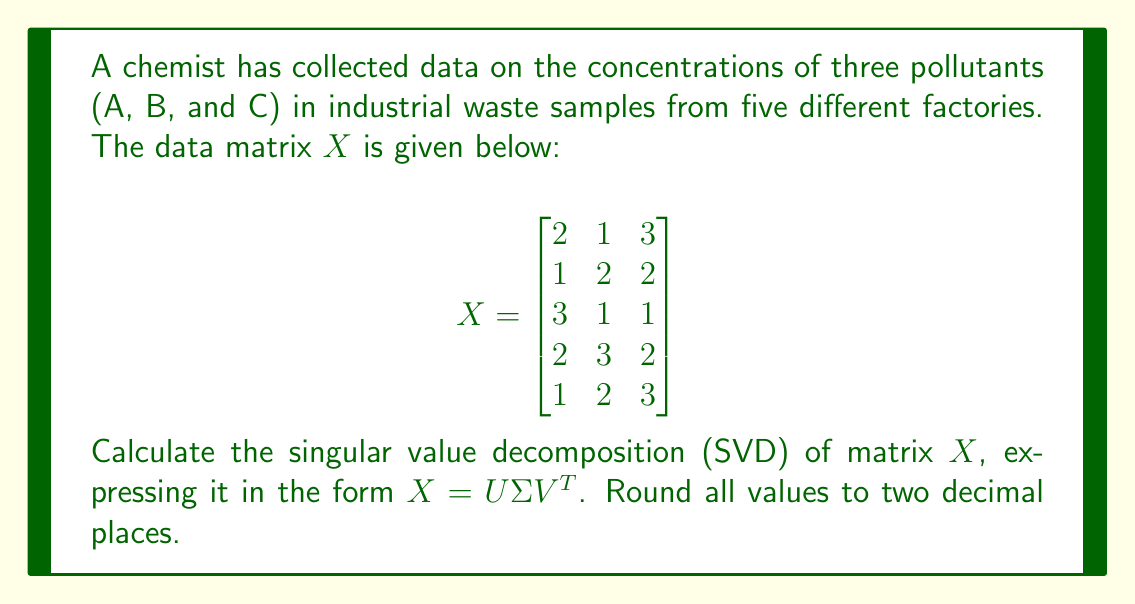Give your solution to this math problem. To calculate the singular value decomposition (SVD) of matrix $X$, we follow these steps:

1. Calculate $X^TX$ and $XX^T$:

   $$X^TX = \begin{bmatrix}
   23 & 19 & 21 \\
   19 & 23 & 21 \\
   21 & 21 & 27
   \end{bmatrix}$$

   $$XX^T = \begin{bmatrix}
   14 & 11 & 11 & 13 & 14 \\
   11 & 9 & 8 & 12 & 11 \\
   11 & 8 & 11 & 11 & 9 \\
   13 & 12 & 11 & 17 & 14 \\
   14 & 11 & 9 & 14 & 14
   \end{bmatrix}$$

2. Find eigenvalues and eigenvectors of $X^TX$:
   Eigenvalues: $\lambda_1 \approx 62.62$, $\lambda_2 \approx 9.38$, $\lambda_3 \approx 1.00$
   
   Corresponding eigenvectors (columns of $V$):
   $$V \approx \begin{bmatrix}
   0.58 & -0.57 & 0.58 \\
   0.57 & 0.82 & 0.00 \\
   0.58 & -0.01 & -0.81
   \end{bmatrix}$$

3. Calculate singular values:
   $\sigma_1 = \sqrt{62.62} \approx 7.91$
   $\sigma_2 = \sqrt{9.38} \approx 3.06$
   $\sigma_3 = \sqrt{1.00} = 1.00$

4. Construct $\Sigma$:
   $$\Sigma = \begin{bmatrix}
   7.91 & 0 & 0 \\
   0 & 3.06 & 0 \\
   0 & 0 & 1.00 \\
   0 & 0 & 0 \\
   0 & 0 & 0
   \end{bmatrix}$$

5. Calculate $U$:
   $U_i = \frac{1}{\sigma_i}XV_i$ for $i = 1, 2, 3$
   
   $$U \approx \begin{bmatrix}
   0.39 & -0.07 & 0.59 \\
   0.33 & 0.74 & -0.26 \\
   0.33 & -0.62 & -0.49 \\
   0.51 & 0.23 & -0.01 \\
   0.61 & -0.09 & 0.58
   \end{bmatrix}$$

6. Verify $X = U\Sigma V^T$
Answer: $X = U\Sigma V^T$, where:
$U \approx \begin{bmatrix}
0.39 & -0.07 & 0.59 \\
0.33 & 0.74 & -0.26 \\
0.33 & -0.62 & -0.49 \\
0.51 & 0.23 & -0.01 \\
0.61 & -0.09 & 0.58
\end{bmatrix}$,
$\Sigma \approx \begin{bmatrix}
7.91 & 0 & 0 \\
0 & 3.06 & 0 \\
0 & 0 & 1.00 \\
0 & 0 & 0 \\
0 & 0 & 0
\end{bmatrix}$,
$V^T \approx \begin{bmatrix}
0.58 & 0.57 & 0.58 \\
-0.57 & 0.82 & -0.01 \\
0.58 & 0.00 & -0.81
\end{bmatrix}$ 